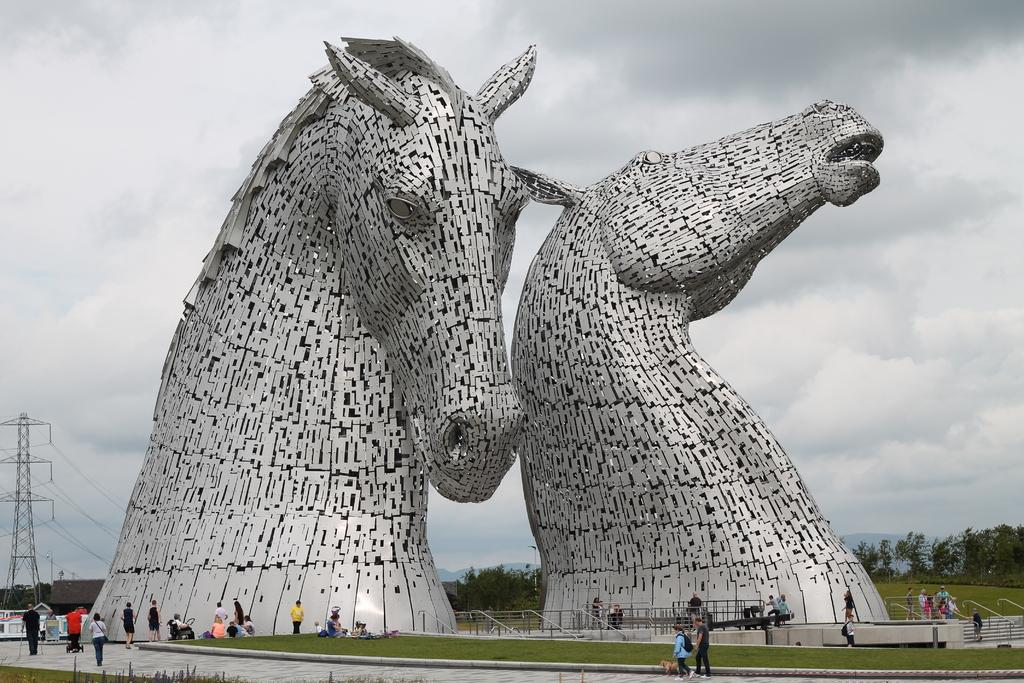What type of sculptures can be seen in the image? There are horse sculptures in the image. What are the people in the image doing? The people in the image are walking around the sculptures. What type of vegetation is visible in the image? There are trees visible in the image. What type of ground surface is present in the image? There is grass in the image. Where is the flock of hens located in the image? There is no flock of hens present in the image. What type of board can be seen in the image? There is no board present in the image. 